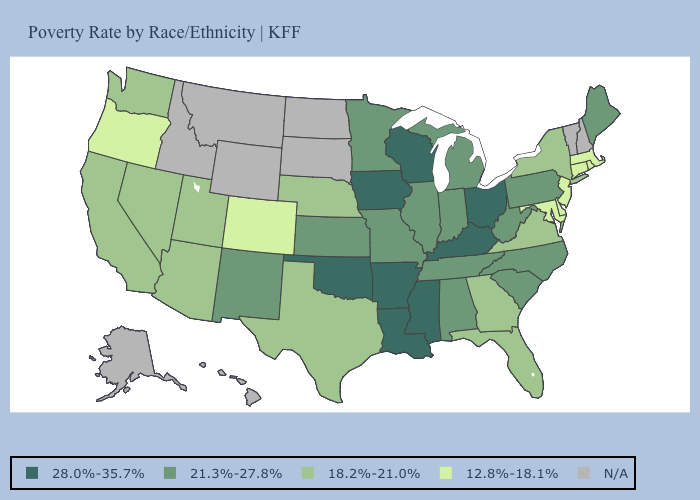What is the lowest value in the South?
Short answer required. 12.8%-18.1%. Is the legend a continuous bar?
Write a very short answer. No. What is the value of Nevada?
Short answer required. 18.2%-21.0%. Name the states that have a value in the range 18.2%-21.0%?
Write a very short answer. Arizona, California, Florida, Georgia, Nebraska, Nevada, New York, Texas, Utah, Virginia, Washington. What is the lowest value in states that border Nebraska?
Be succinct. 12.8%-18.1%. Does Nebraska have the lowest value in the MidWest?
Be succinct. Yes. What is the value of Montana?
Keep it brief. N/A. What is the lowest value in the South?
Be succinct. 12.8%-18.1%. Among the states that border California , which have the lowest value?
Short answer required. Oregon. What is the highest value in states that border Virginia?
Write a very short answer. 28.0%-35.7%. Name the states that have a value in the range 28.0%-35.7%?
Short answer required. Arkansas, Iowa, Kentucky, Louisiana, Mississippi, Ohio, Oklahoma, Wisconsin. What is the value of Missouri?
Keep it brief. 21.3%-27.8%. 